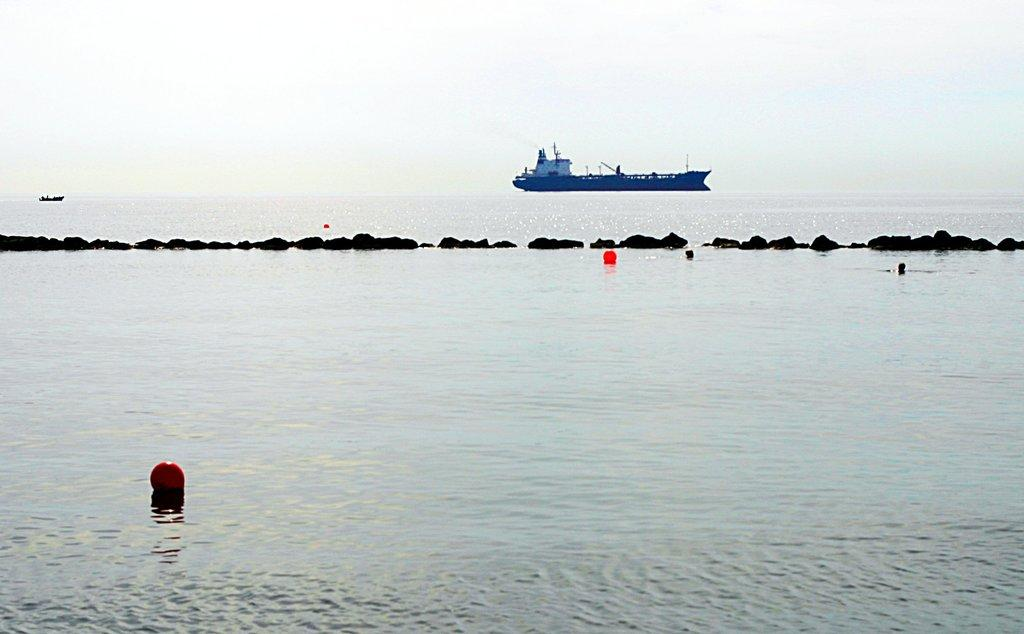What is floating on the water in the image? There are balls floating on the water in the image. What can be seen separating the water from the land in the image? There is a barrier visible in the image. What type of vehicles can be seen in the water in the background of the image? There are ships in the water in the background of the image. What is visible above the water and barrier in the image? The sky is visible in the image. How would you describe the weather based on the appearance of the sky in the image? The sky appears to be cloudy in the image. How many oranges are being carried by the pig in the image? There is no pig or oranges present in the image. What is the end result of the ships in the image? The image does not depict the end result of the ships; it only shows them in the water. 